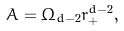<formula> <loc_0><loc_0><loc_500><loc_500>A = \Omega _ { d - 2 } r _ { + } ^ { d - 2 } ,</formula> 